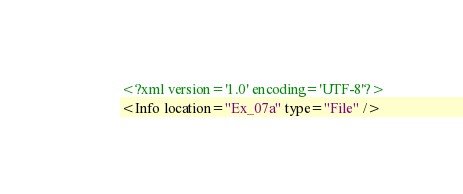<code> <loc_0><loc_0><loc_500><loc_500><_XML_><?xml version='1.0' encoding='UTF-8'?>
<Info location="Ex_07a" type="File" /></code> 